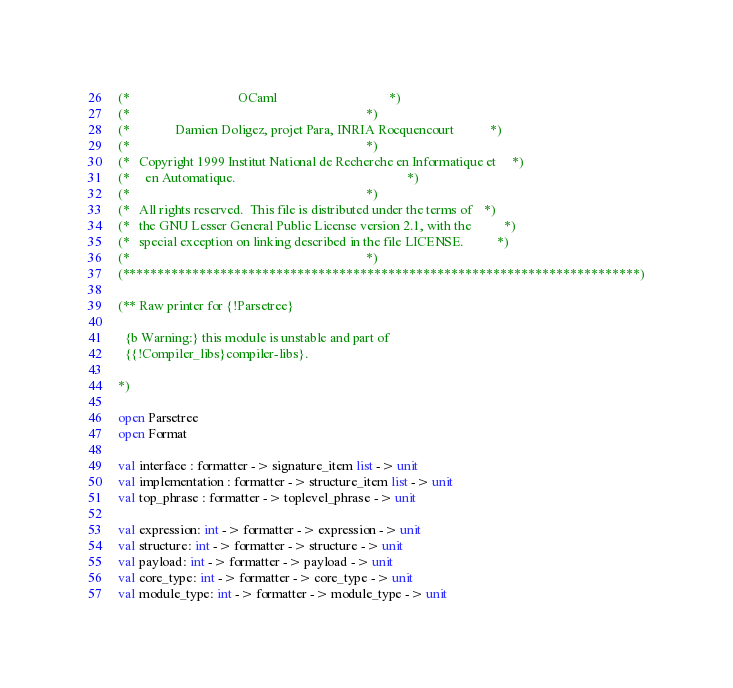Convert code to text. <code><loc_0><loc_0><loc_500><loc_500><_OCaml_>(*                                 OCaml                                  *)
(*                                                                        *)
(*              Damien Doligez, projet Para, INRIA Rocquencourt           *)
(*                                                                        *)
(*   Copyright 1999 Institut National de Recherche en Informatique et     *)
(*     en Automatique.                                                    *)
(*                                                                        *)
(*   All rights reserved.  This file is distributed under the terms of    *)
(*   the GNU Lesser General Public License version 2.1, with the          *)
(*   special exception on linking described in the file LICENSE.          *)
(*                                                                        *)
(**************************************************************************)

(** Raw printer for {!Parsetree}

  {b Warning:} this module is unstable and part of
  {{!Compiler_libs}compiler-libs}.

*)

open Parsetree
open Format

val interface : formatter -> signature_item list -> unit
val implementation : formatter -> structure_item list -> unit
val top_phrase : formatter -> toplevel_phrase -> unit

val expression: int -> formatter -> expression -> unit
val structure: int -> formatter -> structure -> unit
val payload: int -> formatter -> payload -> unit
val core_type: int -> formatter -> core_type -> unit
val module_type: int -> formatter -> module_type -> unit
</code> 